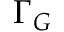Convert formula to latex. <formula><loc_0><loc_0><loc_500><loc_500>\Gamma _ { G }</formula> 